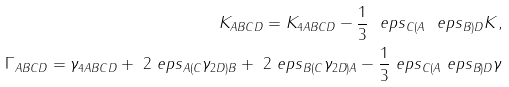Convert formula to latex. <formula><loc_0><loc_0><loc_500><loc_500>K _ { A B C D } = K _ { 4 A B C D } - \frac { 1 } { 3 } \ e p s _ { C ( A } \ e p s _ { B ) D } K , \\ \Gamma _ { A B C D } = \gamma _ { 4 A B C D } + \ 2 \ e p s _ { A ( C } \gamma _ { 2 D ) B } + \ 2 \ e p s _ { B ( C } \gamma _ { 2 D ) A } - \frac { 1 } { 3 } \ e p s _ { C ( A } \ e p s _ { B ) D } \gamma \\</formula> 